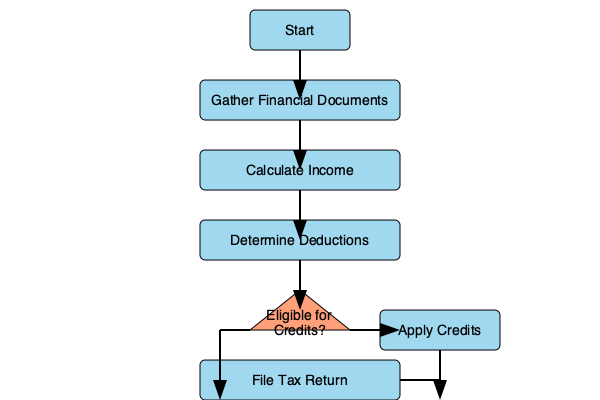According to the flowchart, at which stage in the tax filing process for small businesses would a bakery owner determine if they are eligible for specialized tax credits, such as those for energy-efficient equipment or hiring practices? To answer this question, let's follow the steps in the flowchart:

1. The process starts with gathering financial documents.
2. Next, the bakery owner calculates their income.
3. After that, they determine deductions applicable to their business.
4. Following the deductions, there is a decision point represented by a diamond shape. This shape asks, "Eligible for Credits?"

This decision point is the key to answering the question. It's at this stage that the bakery owner would determine if they are eligible for specialized tax credits. These could include credits for:

- Energy-efficient equipment (e.g., ovens, refrigerators)
- Hiring practices (e.g., employing veterans or people with disabilities)
- Research and development of new baking techniques or recipes
- Small business healthcare tax credit

If the answer is "Yes" to being eligible for credits, the flowchart directs to "Apply Credits" before filing the tax return. If "No," it goes directly to filing the tax return.

Therefore, the stage at which a bakery owner would determine eligibility for specialized tax credits is immediately after determining deductions and before potentially applying those credits or filing the tax return.
Answer: After determining deductions 